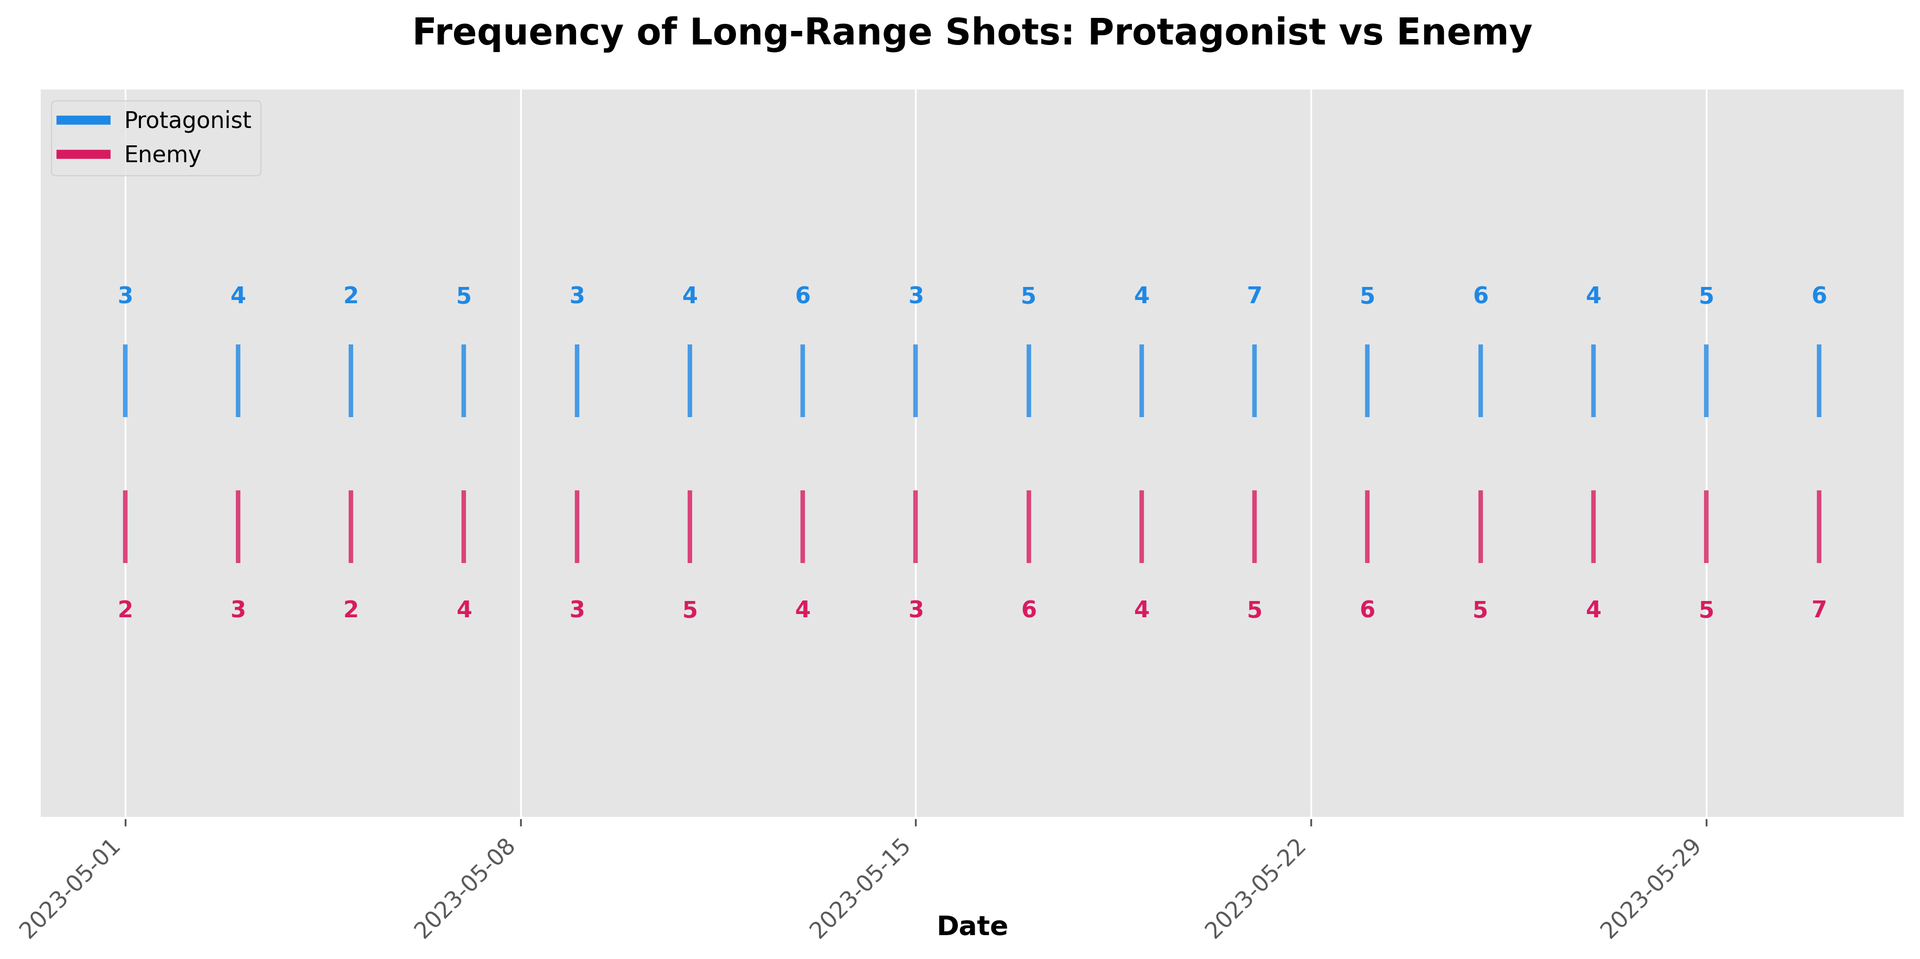What date had the highest combined total of long-range shots by the protagonist and enemy? First, add the number of shots taken by both the protagonist and the enemy for each date. The highest combined total is on 2023-05-31, where the protagonist had 6 shots and the enemy had 7 shots, summing to 13 shots.
Answer: 2023-05-31 On which date did the protagonist have the highest number of shots, and how many were there? Look through the data for the highest number recorded under the protagonist. The highest number of shots taken by the protagonist is 7 on 2023-05-21.
Answer: 2023-05-21, 7 shots How many times did the enemy take more shots than the protagonist? Compare the shots taken by the enemy and the protagonist for each date. The enemy took more shots on 2023-05-11, 2023-05-17, 2023-05-23, and 2023-05-31. This happened 4 times.
Answer: 4 times What is the average number of shots taken by the protagonist throughout the month? Sum all the shots taken by the protagonist and divide by the total number of dates (which is 16). The total is 68, so the average is 68/16.
Answer: 4.25 shots Which date had an equal number of shots taken by both the protagonist and the enemy? Find dates where the protagonist’s and enemy’s numbers are equal. These dates are 2023-05-01, 2023-05-05, 2023-05-09, 2023-05-15, 2023-05-19, and 2023-05-27.
Answer: 2023-05-01, 2023-05-05, 2023-05-09, 2023-05-15, 2023-05-19, 2023-05-27 On which date did the combined total of shots taken (by both protagonist and enemy) first exceed 10? Calculate the combined total of shots for each date and identify the first date where the sum exceeds 10. This occurred on 2023-05-07 (5+4=9, but there's no prior higher total until 5+4).
Answer: 2023-05-21 What is the difference in the total number of shots taken by the enemy and the protagonist over the month? Sum all the shots for both the protagonist and the enemy separately (68 for the protagonist and 65 for the enemy), then subtract these totals. The difference is 68 - 65.
Answer: 3 Which line color represents the protagonist? Refer to the figure’s legend which associates each color with the respective sniper. The protagonist’s shots are represented by the blue line.
Answer: Blue On how many dates did the enemy take exactly 4 shots? Count the dates where the number of enemy shots is 4. These occur on 2023-05-01, 2023-05-13, 2023-05-19, and 2023-05-27.
Answer: 4 dates 